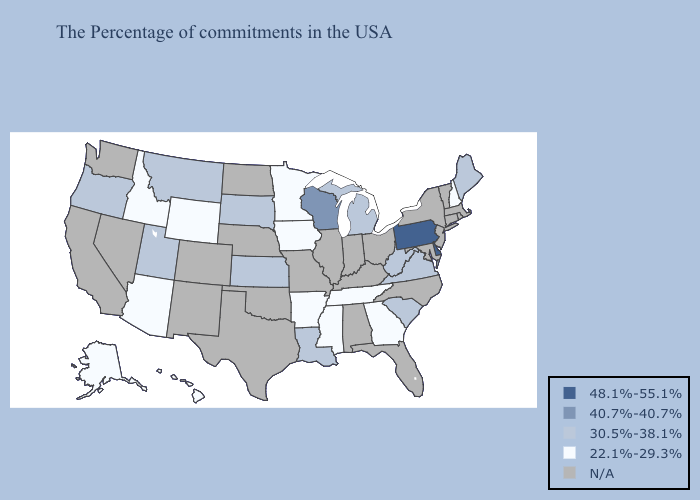Name the states that have a value in the range N/A?
Answer briefly. Massachusetts, Rhode Island, Vermont, Connecticut, New York, New Jersey, Maryland, North Carolina, Ohio, Florida, Kentucky, Indiana, Alabama, Illinois, Missouri, Nebraska, Oklahoma, Texas, North Dakota, Colorado, New Mexico, Nevada, California, Washington. Among the states that border Nebraska , does Iowa have the highest value?
Concise answer only. No. What is the lowest value in the South?
Answer briefly. 22.1%-29.3%. Which states have the lowest value in the South?
Keep it brief. Georgia, Tennessee, Mississippi, Arkansas. What is the highest value in the MidWest ?
Quick response, please. 40.7%-40.7%. Does Arkansas have the lowest value in the South?
Be succinct. Yes. Does the map have missing data?
Short answer required. Yes. What is the value of Vermont?
Write a very short answer. N/A. Which states have the lowest value in the Northeast?
Concise answer only. New Hampshire. What is the highest value in states that border New Hampshire?
Give a very brief answer. 30.5%-38.1%. Name the states that have a value in the range 22.1%-29.3%?
Answer briefly. New Hampshire, Georgia, Tennessee, Mississippi, Arkansas, Minnesota, Iowa, Wyoming, Arizona, Idaho, Alaska, Hawaii. Name the states that have a value in the range 30.5%-38.1%?
Short answer required. Maine, Virginia, South Carolina, West Virginia, Michigan, Louisiana, Kansas, South Dakota, Utah, Montana, Oregon. Name the states that have a value in the range N/A?
Write a very short answer. Massachusetts, Rhode Island, Vermont, Connecticut, New York, New Jersey, Maryland, North Carolina, Ohio, Florida, Kentucky, Indiana, Alabama, Illinois, Missouri, Nebraska, Oklahoma, Texas, North Dakota, Colorado, New Mexico, Nevada, California, Washington. 